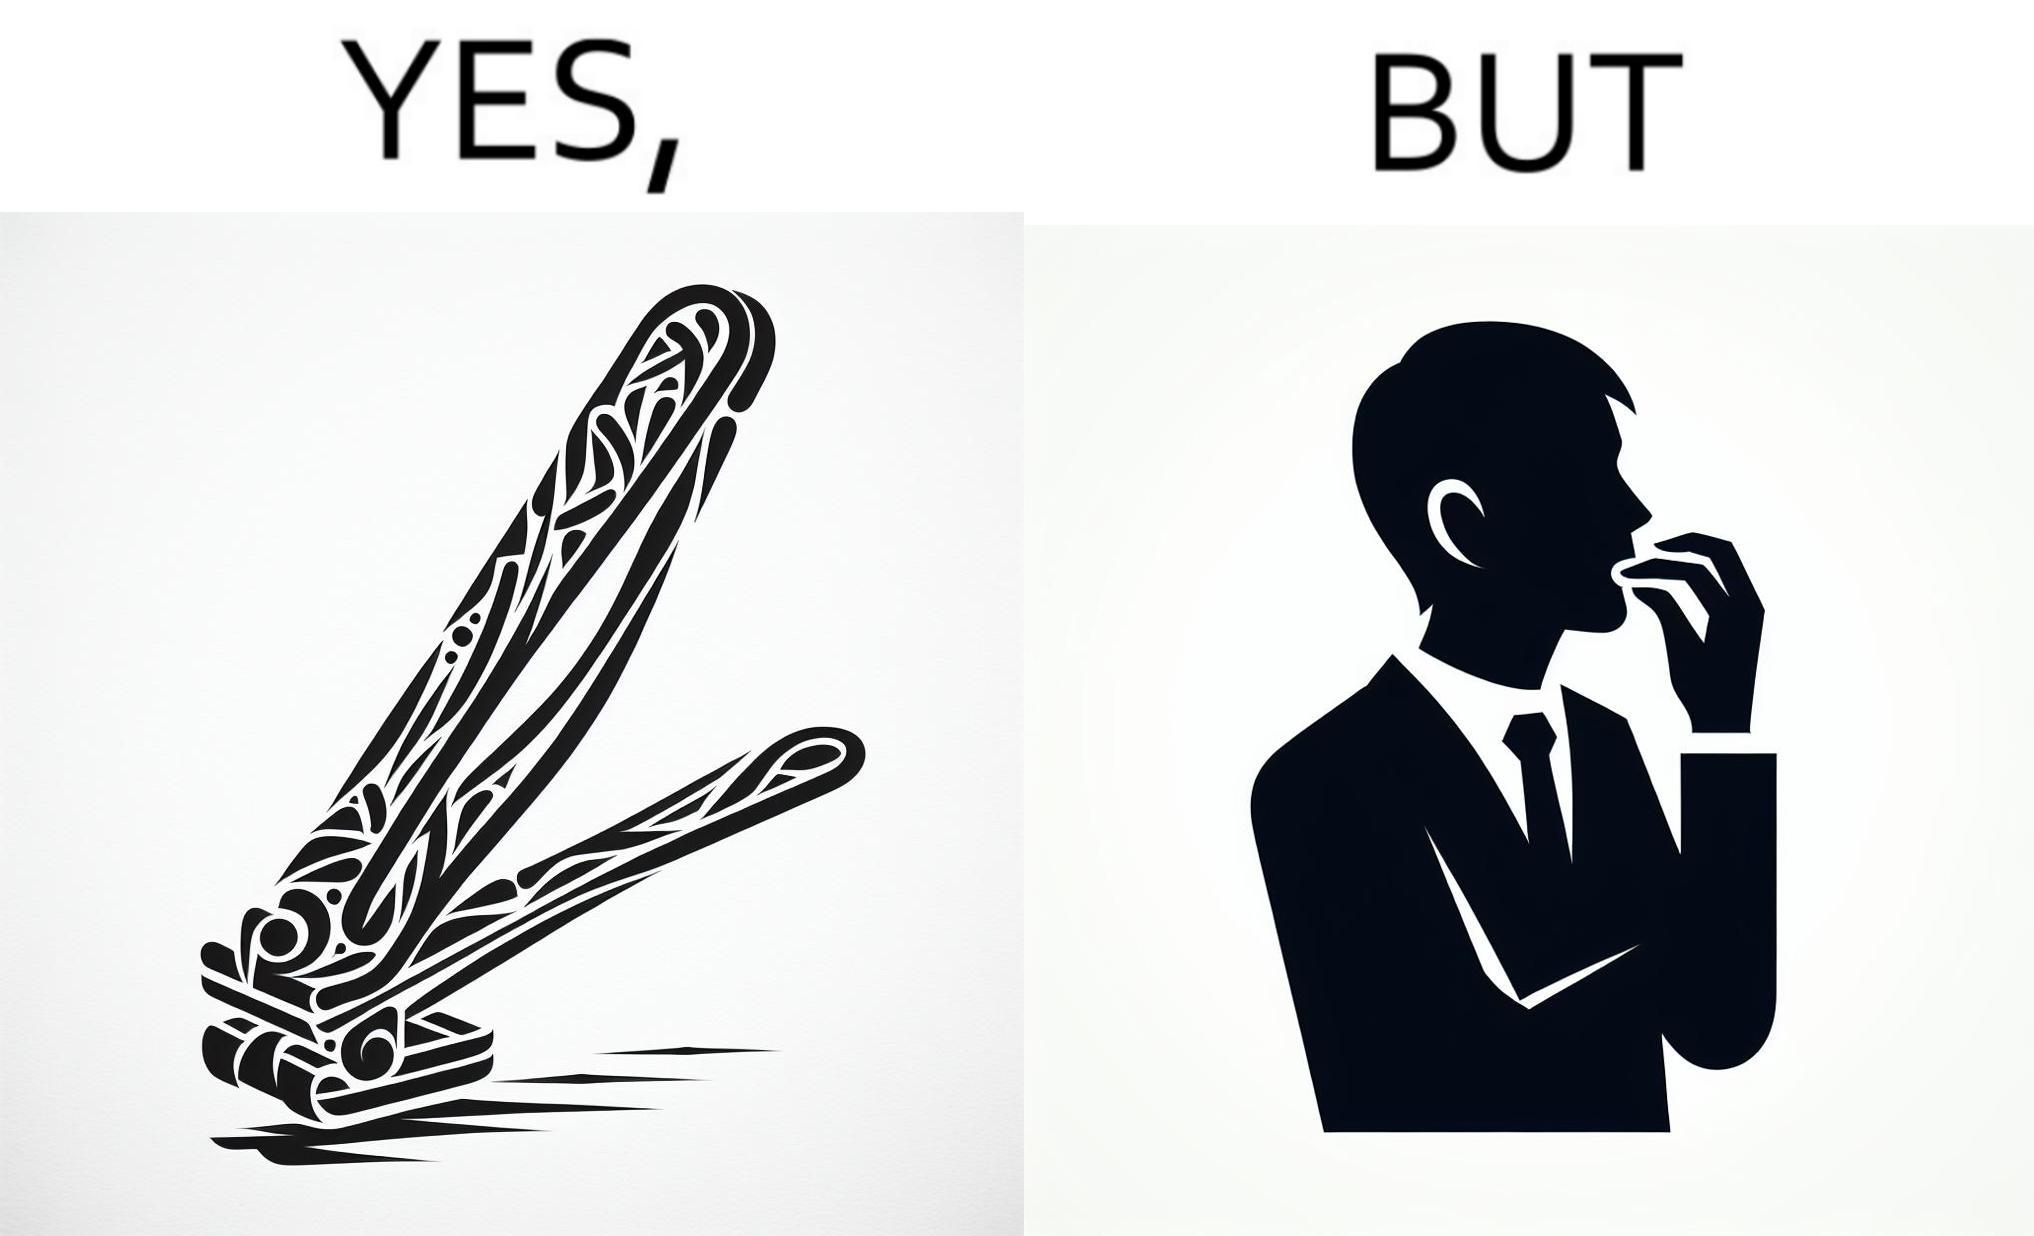Describe what you see in the left and right parts of this image. In the left part of the image: a nail clipper In the right part of the image: a person biting their nails to cut them 